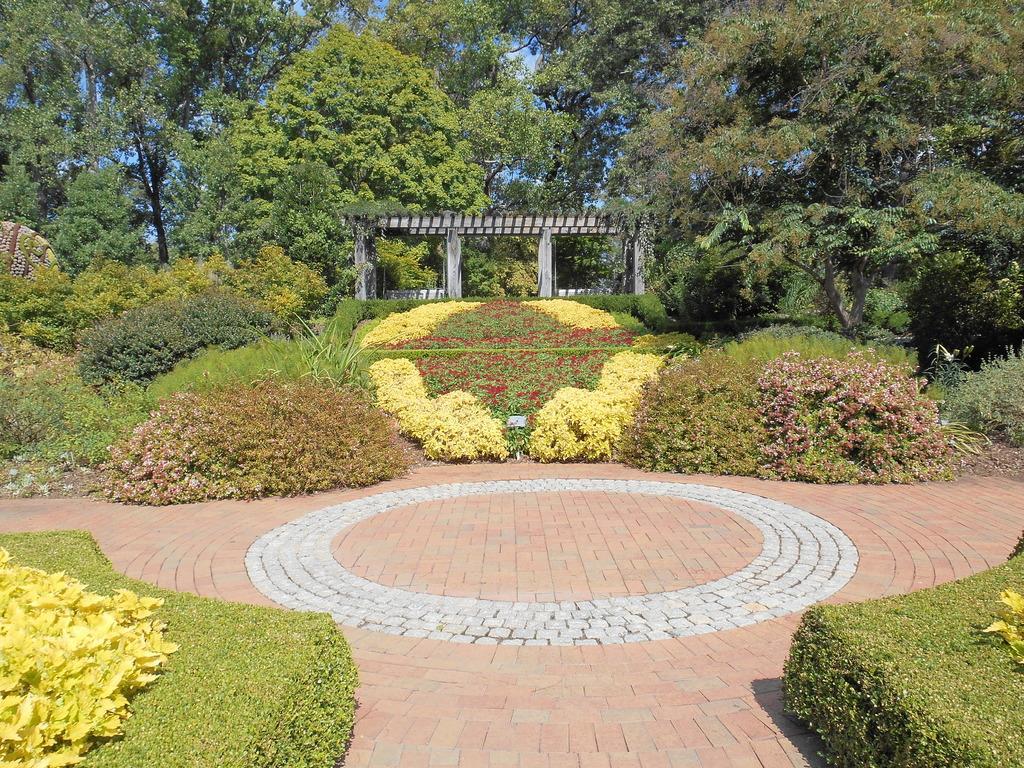Can you describe this image briefly? At the background portion of the image we can see trees, sky and pillars. Front portion of the image we can see bushes, plants and floor. 